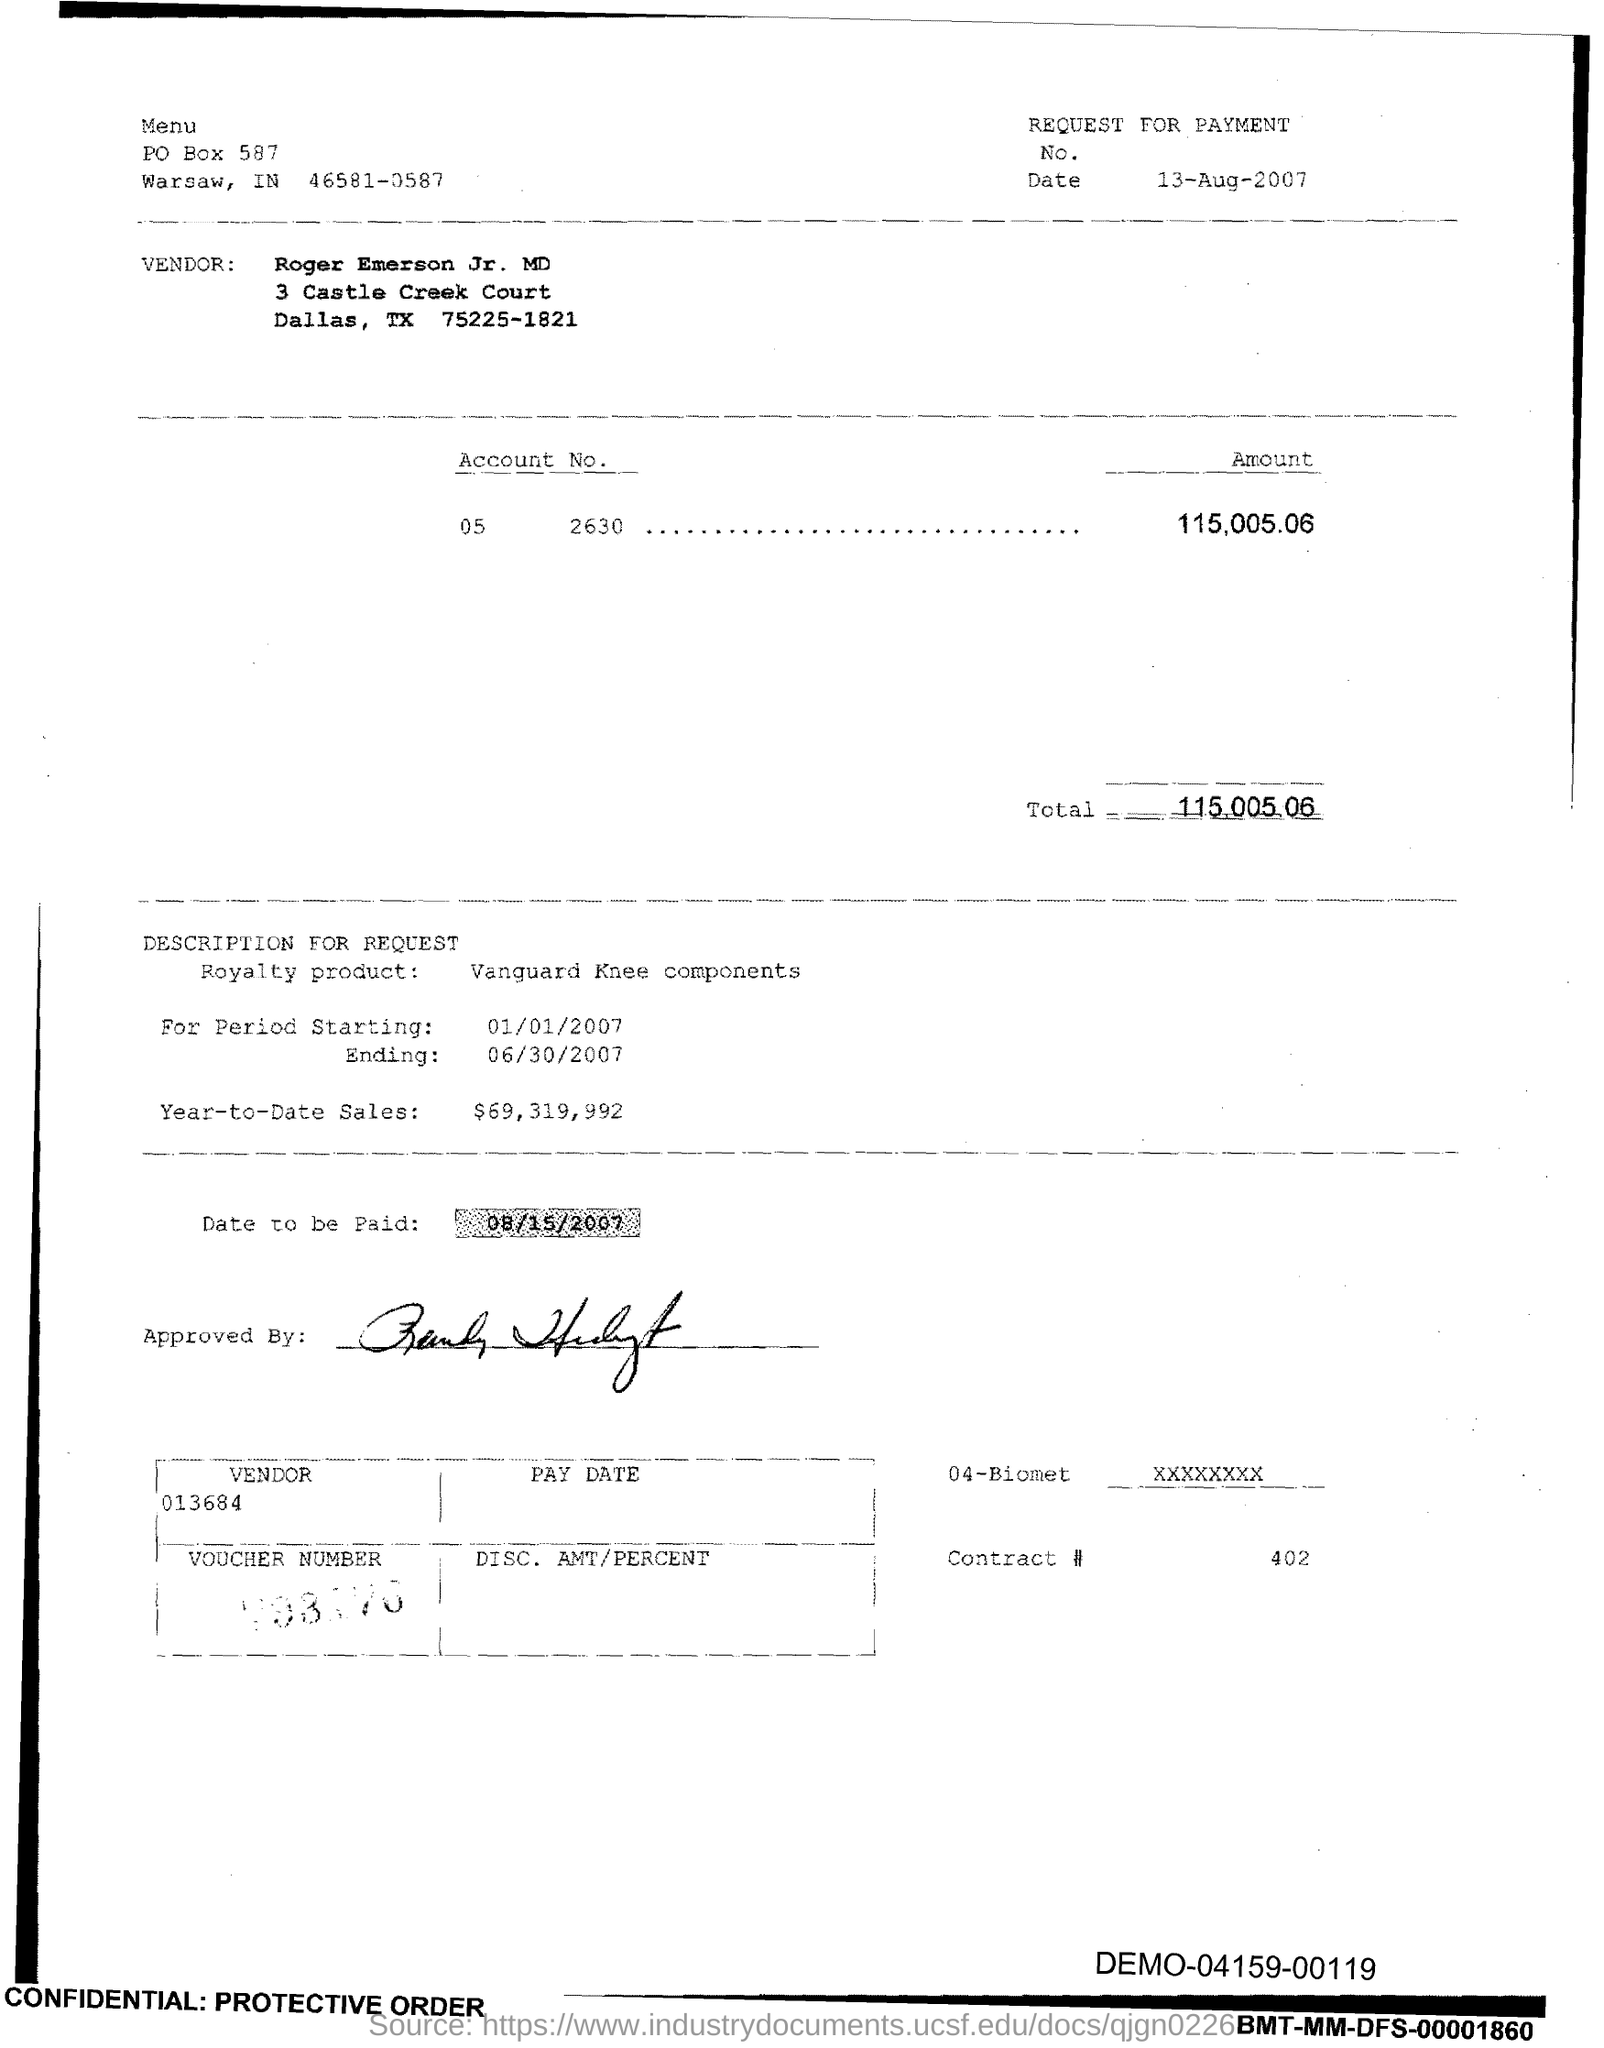What is the issued date of this voucher?
Your response must be concise. 13-Aug-2007. What is the vendor name given in the voucher?
Give a very brief answer. Roger Emerson Jr. MD. What is the Account No. given in the voucher?
Offer a terse response. 05 2630. What is the total amount mentioned in the voucher?
Provide a succinct answer. 115,005.06. What is the royalty product given in the voucher?
Ensure brevity in your answer.  Vanguard Knee components. What is the Year-to-Date Sales of the royalty product?
Ensure brevity in your answer.  69,319,992. What is the start date of the royalty period?
Make the answer very short. 01/01/2007. What is the Contract # given in the voucher?
Ensure brevity in your answer.  402. What is the end date of the royalty period?
Your answer should be compact. 06/30/2007. 